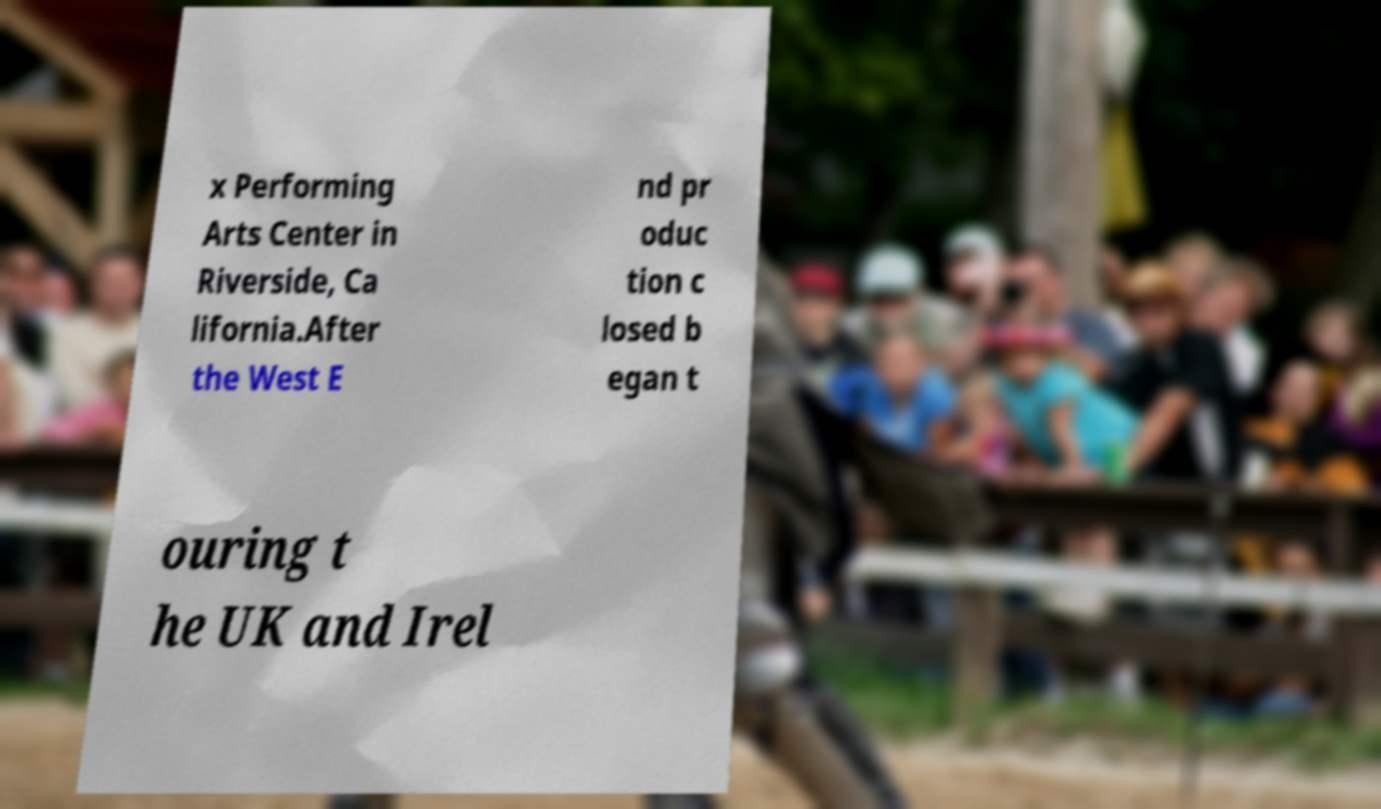Could you assist in decoding the text presented in this image and type it out clearly? x Performing Arts Center in Riverside, Ca lifornia.After the West E nd pr oduc tion c losed b egan t ouring t he UK and Irel 